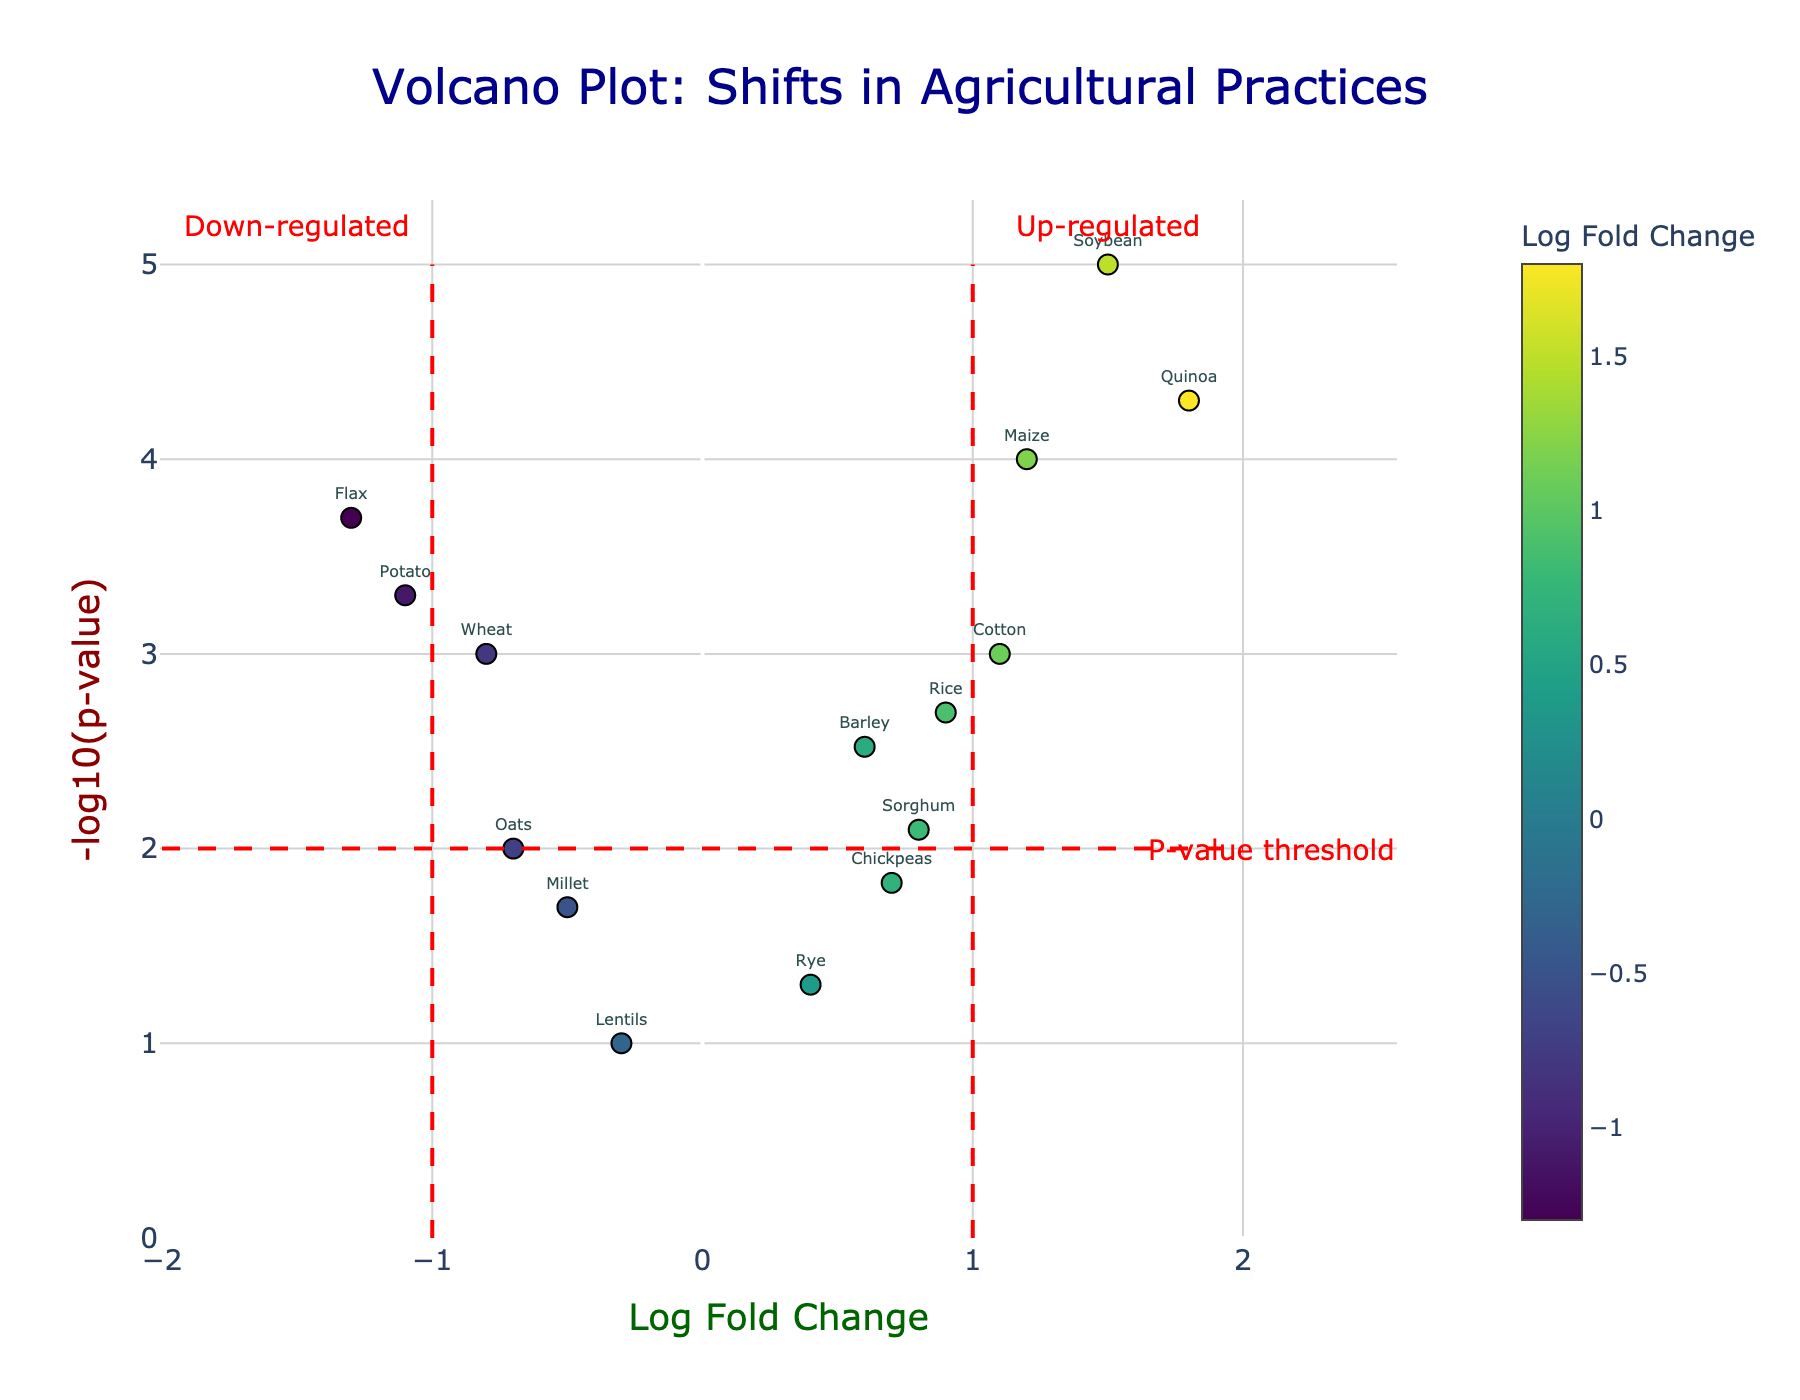How many crops are down-regulated? To determine the number of down-regulated crops, we need to count the data points with a log fold change less than zero. The figure shows the log fold change on the x-axis, with negative values indicating down-regulation.
Answer: 7 Which crop has the highest fold change? The highest fold change corresponds to the largest positive value on the x-axis. Looking at the figure, we identify the point farthest to the right. The hover text helps us identify the specific crop.
Answer: Quinoa What is the p-value threshold line set at in the y-axis? The vertical threshold line for the p-value is where the y-axis, which represents -log10(p-value), intersects with the red dashed line. From the annotations in the figure, this threshold line occurs at a y-value of 2.
Answer: 0.01 Which crops are significantly up-regulated based on the threshold lines? Significance is determined by crops that have a log fold change above 1 or below -1 and a -log10(p-value) above 2. We look at the points beyond these threshold lines. Based on the hover text and their positions, the significantly up-regulated crops are Soybean, Maize, Rice, Quinoa, and Cotton.
Answer: Soybean, Maize, Rice, Quinoa, Cotton How does the fold change of Barley compare to that of Chickpeas? Comparison requires examining their positions on the x-axis, which represents log fold change. Barley has a log fold change of 0.6, and Chickpeas have 0.7. Since 0.7 is greater than 0.6, Chickpeas have a higher fold change.
Answer: Chickpeas have a higher fold change than Barley Which crop with a log fold change less than zero has the smallest p-value? To find the answer, we focus on the data points to the left of zero on the x-axis and select the one with the highest y-value (smallest p-value). The hover text will help identify it. Flax has the smallest p-value among the down-regulated crops.
Answer: Flax Is there any crop with a log fold change around zero but a significant p-value? We need to look for crops near the center of the x-axis (log fold change around zero) and -log10(p-value) greater than 2 (significant). No crop near zero log fold change crosses the horizontal threshold line.
Answer: No What does the color of the markers indicate? The color of the markers represents the log fold change, with a gradient shown by the color scale (Viridis) on the right. Lighter greens typically represent higher log fold changes, while darker colors represent lower or negative fold changes.
Answer: Log fold change 